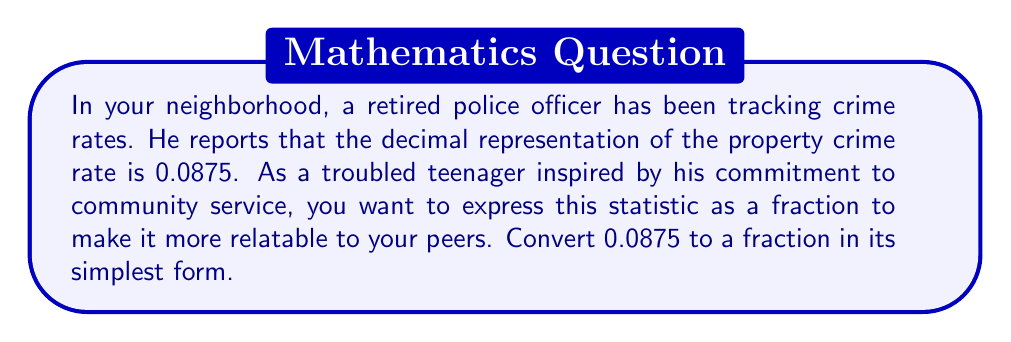Solve this math problem. To convert a decimal to a fraction, we can follow these steps:

1) First, determine how many decimal places the number has. In this case, 0.0875 has 4 decimal places.

2) Multiply both the numerator and denominator by 10^4 (10,000) to move the decimal point:

   $$0.0875 = \frac{0.0875 \times 10000}{10000} = \frac{875}{10000}$$

3) Now we have the fraction 875/10000. To simplify this, we need to find the greatest common divisor (GCD) of 875 and 10000.

4) We can use the Euclidean algorithm to find the GCD:
   
   10000 = 11 × 875 + 375
   875 = 2 × 375 + 125
   375 = 3 × 125 + 0

   Therefore, the GCD is 125.

5) Divide both the numerator and denominator by the GCD:

   $$\frac{875 \div 125}{10000 \div 125} = \frac{7}{80}$$

Thus, 0.0875 simplified to its lowest terms is 7/80.
Answer: $\frac{7}{80}$ 